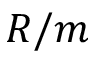Convert formula to latex. <formula><loc_0><loc_0><loc_500><loc_500>R / m</formula> 